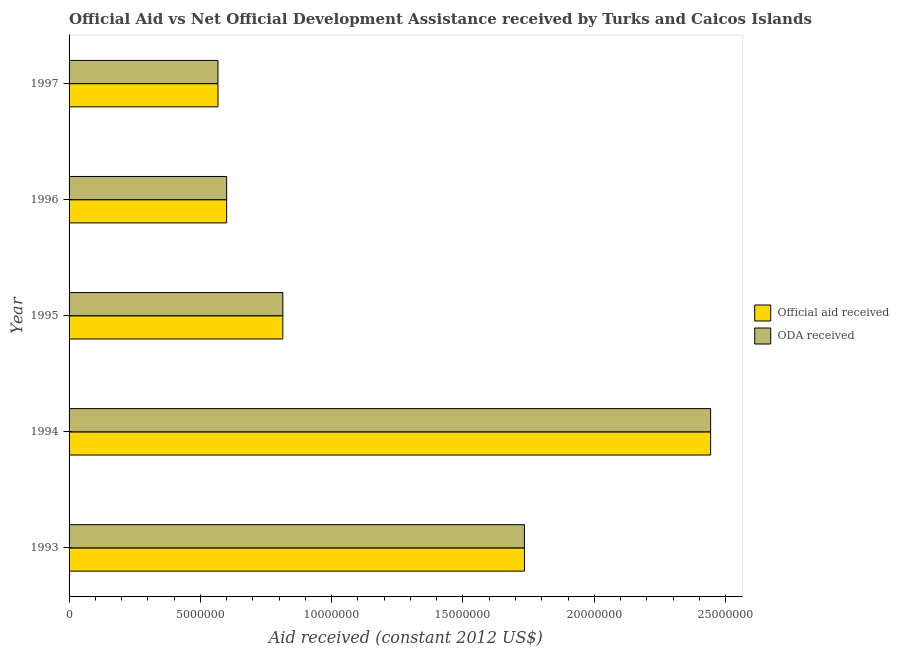How many groups of bars are there?
Offer a terse response. 5. Are the number of bars per tick equal to the number of legend labels?
Your answer should be compact. Yes. How many bars are there on the 2nd tick from the top?
Keep it short and to the point. 2. What is the oda received in 1996?
Provide a short and direct response. 6.00e+06. Across all years, what is the maximum oda received?
Provide a short and direct response. 2.44e+07. Across all years, what is the minimum official aid received?
Provide a succinct answer. 5.67e+06. In which year was the oda received maximum?
Keep it short and to the point. 1994. What is the total official aid received in the graph?
Your response must be concise. 6.16e+07. What is the difference between the official aid received in 1995 and that in 1996?
Make the answer very short. 2.14e+06. What is the difference between the official aid received in 1994 and the oda received in 1993?
Your answer should be very brief. 7.09e+06. What is the average official aid received per year?
Ensure brevity in your answer.  1.23e+07. In how many years, is the oda received greater than 21000000 US$?
Make the answer very short. 1. What is the ratio of the official aid received in 1995 to that in 1997?
Keep it short and to the point. 1.44. What is the difference between the highest and the second highest official aid received?
Make the answer very short. 7.09e+06. What is the difference between the highest and the lowest official aid received?
Keep it short and to the point. 1.88e+07. What does the 1st bar from the top in 1995 represents?
Offer a terse response. ODA received. What does the 2nd bar from the bottom in 1995 represents?
Offer a very short reply. ODA received. Are the values on the major ticks of X-axis written in scientific E-notation?
Your answer should be compact. No. Does the graph contain any zero values?
Your answer should be compact. No. How many legend labels are there?
Provide a succinct answer. 2. What is the title of the graph?
Ensure brevity in your answer.  Official Aid vs Net Official Development Assistance received by Turks and Caicos Islands . Does "Secondary school" appear as one of the legend labels in the graph?
Make the answer very short. No. What is the label or title of the X-axis?
Ensure brevity in your answer.  Aid received (constant 2012 US$). What is the label or title of the Y-axis?
Ensure brevity in your answer.  Year. What is the Aid received (constant 2012 US$) of Official aid received in 1993?
Ensure brevity in your answer.  1.73e+07. What is the Aid received (constant 2012 US$) of ODA received in 1993?
Keep it short and to the point. 1.73e+07. What is the Aid received (constant 2012 US$) of Official aid received in 1994?
Give a very brief answer. 2.44e+07. What is the Aid received (constant 2012 US$) of ODA received in 1994?
Your answer should be compact. 2.44e+07. What is the Aid received (constant 2012 US$) of Official aid received in 1995?
Keep it short and to the point. 8.14e+06. What is the Aid received (constant 2012 US$) of ODA received in 1995?
Your answer should be compact. 8.14e+06. What is the Aid received (constant 2012 US$) of Official aid received in 1996?
Provide a short and direct response. 6.00e+06. What is the Aid received (constant 2012 US$) of ODA received in 1996?
Your answer should be very brief. 6.00e+06. What is the Aid received (constant 2012 US$) in Official aid received in 1997?
Offer a terse response. 5.67e+06. What is the Aid received (constant 2012 US$) of ODA received in 1997?
Your response must be concise. 5.67e+06. Across all years, what is the maximum Aid received (constant 2012 US$) in Official aid received?
Make the answer very short. 2.44e+07. Across all years, what is the maximum Aid received (constant 2012 US$) in ODA received?
Keep it short and to the point. 2.44e+07. Across all years, what is the minimum Aid received (constant 2012 US$) in Official aid received?
Make the answer very short. 5.67e+06. Across all years, what is the minimum Aid received (constant 2012 US$) in ODA received?
Keep it short and to the point. 5.67e+06. What is the total Aid received (constant 2012 US$) of Official aid received in the graph?
Your answer should be compact. 6.16e+07. What is the total Aid received (constant 2012 US$) of ODA received in the graph?
Offer a very short reply. 6.16e+07. What is the difference between the Aid received (constant 2012 US$) of Official aid received in 1993 and that in 1994?
Keep it short and to the point. -7.09e+06. What is the difference between the Aid received (constant 2012 US$) of ODA received in 1993 and that in 1994?
Ensure brevity in your answer.  -7.09e+06. What is the difference between the Aid received (constant 2012 US$) of Official aid received in 1993 and that in 1995?
Your answer should be compact. 9.20e+06. What is the difference between the Aid received (constant 2012 US$) of ODA received in 1993 and that in 1995?
Provide a succinct answer. 9.20e+06. What is the difference between the Aid received (constant 2012 US$) of Official aid received in 1993 and that in 1996?
Your response must be concise. 1.13e+07. What is the difference between the Aid received (constant 2012 US$) in ODA received in 1993 and that in 1996?
Offer a terse response. 1.13e+07. What is the difference between the Aid received (constant 2012 US$) of Official aid received in 1993 and that in 1997?
Provide a short and direct response. 1.17e+07. What is the difference between the Aid received (constant 2012 US$) of ODA received in 1993 and that in 1997?
Offer a terse response. 1.17e+07. What is the difference between the Aid received (constant 2012 US$) in Official aid received in 1994 and that in 1995?
Provide a short and direct response. 1.63e+07. What is the difference between the Aid received (constant 2012 US$) in ODA received in 1994 and that in 1995?
Provide a succinct answer. 1.63e+07. What is the difference between the Aid received (constant 2012 US$) in Official aid received in 1994 and that in 1996?
Your response must be concise. 1.84e+07. What is the difference between the Aid received (constant 2012 US$) in ODA received in 1994 and that in 1996?
Make the answer very short. 1.84e+07. What is the difference between the Aid received (constant 2012 US$) in Official aid received in 1994 and that in 1997?
Your response must be concise. 1.88e+07. What is the difference between the Aid received (constant 2012 US$) in ODA received in 1994 and that in 1997?
Offer a very short reply. 1.88e+07. What is the difference between the Aid received (constant 2012 US$) of Official aid received in 1995 and that in 1996?
Give a very brief answer. 2.14e+06. What is the difference between the Aid received (constant 2012 US$) in ODA received in 1995 and that in 1996?
Your answer should be compact. 2.14e+06. What is the difference between the Aid received (constant 2012 US$) in Official aid received in 1995 and that in 1997?
Give a very brief answer. 2.47e+06. What is the difference between the Aid received (constant 2012 US$) of ODA received in 1995 and that in 1997?
Give a very brief answer. 2.47e+06. What is the difference between the Aid received (constant 2012 US$) in Official aid received in 1996 and that in 1997?
Make the answer very short. 3.30e+05. What is the difference between the Aid received (constant 2012 US$) of ODA received in 1996 and that in 1997?
Provide a succinct answer. 3.30e+05. What is the difference between the Aid received (constant 2012 US$) of Official aid received in 1993 and the Aid received (constant 2012 US$) of ODA received in 1994?
Your response must be concise. -7.09e+06. What is the difference between the Aid received (constant 2012 US$) of Official aid received in 1993 and the Aid received (constant 2012 US$) of ODA received in 1995?
Your answer should be compact. 9.20e+06. What is the difference between the Aid received (constant 2012 US$) of Official aid received in 1993 and the Aid received (constant 2012 US$) of ODA received in 1996?
Provide a succinct answer. 1.13e+07. What is the difference between the Aid received (constant 2012 US$) of Official aid received in 1993 and the Aid received (constant 2012 US$) of ODA received in 1997?
Your answer should be compact. 1.17e+07. What is the difference between the Aid received (constant 2012 US$) of Official aid received in 1994 and the Aid received (constant 2012 US$) of ODA received in 1995?
Ensure brevity in your answer.  1.63e+07. What is the difference between the Aid received (constant 2012 US$) in Official aid received in 1994 and the Aid received (constant 2012 US$) in ODA received in 1996?
Give a very brief answer. 1.84e+07. What is the difference between the Aid received (constant 2012 US$) in Official aid received in 1994 and the Aid received (constant 2012 US$) in ODA received in 1997?
Offer a very short reply. 1.88e+07. What is the difference between the Aid received (constant 2012 US$) of Official aid received in 1995 and the Aid received (constant 2012 US$) of ODA received in 1996?
Provide a short and direct response. 2.14e+06. What is the difference between the Aid received (constant 2012 US$) in Official aid received in 1995 and the Aid received (constant 2012 US$) in ODA received in 1997?
Keep it short and to the point. 2.47e+06. What is the difference between the Aid received (constant 2012 US$) in Official aid received in 1996 and the Aid received (constant 2012 US$) in ODA received in 1997?
Ensure brevity in your answer.  3.30e+05. What is the average Aid received (constant 2012 US$) in Official aid received per year?
Provide a short and direct response. 1.23e+07. What is the average Aid received (constant 2012 US$) of ODA received per year?
Your response must be concise. 1.23e+07. In the year 1993, what is the difference between the Aid received (constant 2012 US$) in Official aid received and Aid received (constant 2012 US$) in ODA received?
Your answer should be compact. 0. In the year 1994, what is the difference between the Aid received (constant 2012 US$) of Official aid received and Aid received (constant 2012 US$) of ODA received?
Your answer should be compact. 0. In the year 1995, what is the difference between the Aid received (constant 2012 US$) in Official aid received and Aid received (constant 2012 US$) in ODA received?
Your response must be concise. 0. In the year 1996, what is the difference between the Aid received (constant 2012 US$) in Official aid received and Aid received (constant 2012 US$) in ODA received?
Offer a terse response. 0. In the year 1997, what is the difference between the Aid received (constant 2012 US$) of Official aid received and Aid received (constant 2012 US$) of ODA received?
Give a very brief answer. 0. What is the ratio of the Aid received (constant 2012 US$) of Official aid received in 1993 to that in 1994?
Provide a succinct answer. 0.71. What is the ratio of the Aid received (constant 2012 US$) in ODA received in 1993 to that in 1994?
Offer a very short reply. 0.71. What is the ratio of the Aid received (constant 2012 US$) in Official aid received in 1993 to that in 1995?
Offer a very short reply. 2.13. What is the ratio of the Aid received (constant 2012 US$) in ODA received in 1993 to that in 1995?
Make the answer very short. 2.13. What is the ratio of the Aid received (constant 2012 US$) of Official aid received in 1993 to that in 1996?
Provide a succinct answer. 2.89. What is the ratio of the Aid received (constant 2012 US$) in ODA received in 1993 to that in 1996?
Keep it short and to the point. 2.89. What is the ratio of the Aid received (constant 2012 US$) in Official aid received in 1993 to that in 1997?
Your answer should be very brief. 3.06. What is the ratio of the Aid received (constant 2012 US$) of ODA received in 1993 to that in 1997?
Offer a terse response. 3.06. What is the ratio of the Aid received (constant 2012 US$) of Official aid received in 1994 to that in 1995?
Offer a very short reply. 3. What is the ratio of the Aid received (constant 2012 US$) of ODA received in 1994 to that in 1995?
Offer a very short reply. 3. What is the ratio of the Aid received (constant 2012 US$) in Official aid received in 1994 to that in 1996?
Keep it short and to the point. 4.07. What is the ratio of the Aid received (constant 2012 US$) in ODA received in 1994 to that in 1996?
Offer a very short reply. 4.07. What is the ratio of the Aid received (constant 2012 US$) of Official aid received in 1994 to that in 1997?
Provide a short and direct response. 4.31. What is the ratio of the Aid received (constant 2012 US$) of ODA received in 1994 to that in 1997?
Ensure brevity in your answer.  4.31. What is the ratio of the Aid received (constant 2012 US$) of Official aid received in 1995 to that in 1996?
Ensure brevity in your answer.  1.36. What is the ratio of the Aid received (constant 2012 US$) in ODA received in 1995 to that in 1996?
Ensure brevity in your answer.  1.36. What is the ratio of the Aid received (constant 2012 US$) of Official aid received in 1995 to that in 1997?
Offer a very short reply. 1.44. What is the ratio of the Aid received (constant 2012 US$) in ODA received in 1995 to that in 1997?
Provide a succinct answer. 1.44. What is the ratio of the Aid received (constant 2012 US$) of Official aid received in 1996 to that in 1997?
Offer a terse response. 1.06. What is the ratio of the Aid received (constant 2012 US$) of ODA received in 1996 to that in 1997?
Give a very brief answer. 1.06. What is the difference between the highest and the second highest Aid received (constant 2012 US$) of Official aid received?
Provide a short and direct response. 7.09e+06. What is the difference between the highest and the second highest Aid received (constant 2012 US$) in ODA received?
Your answer should be very brief. 7.09e+06. What is the difference between the highest and the lowest Aid received (constant 2012 US$) of Official aid received?
Provide a short and direct response. 1.88e+07. What is the difference between the highest and the lowest Aid received (constant 2012 US$) in ODA received?
Offer a terse response. 1.88e+07. 